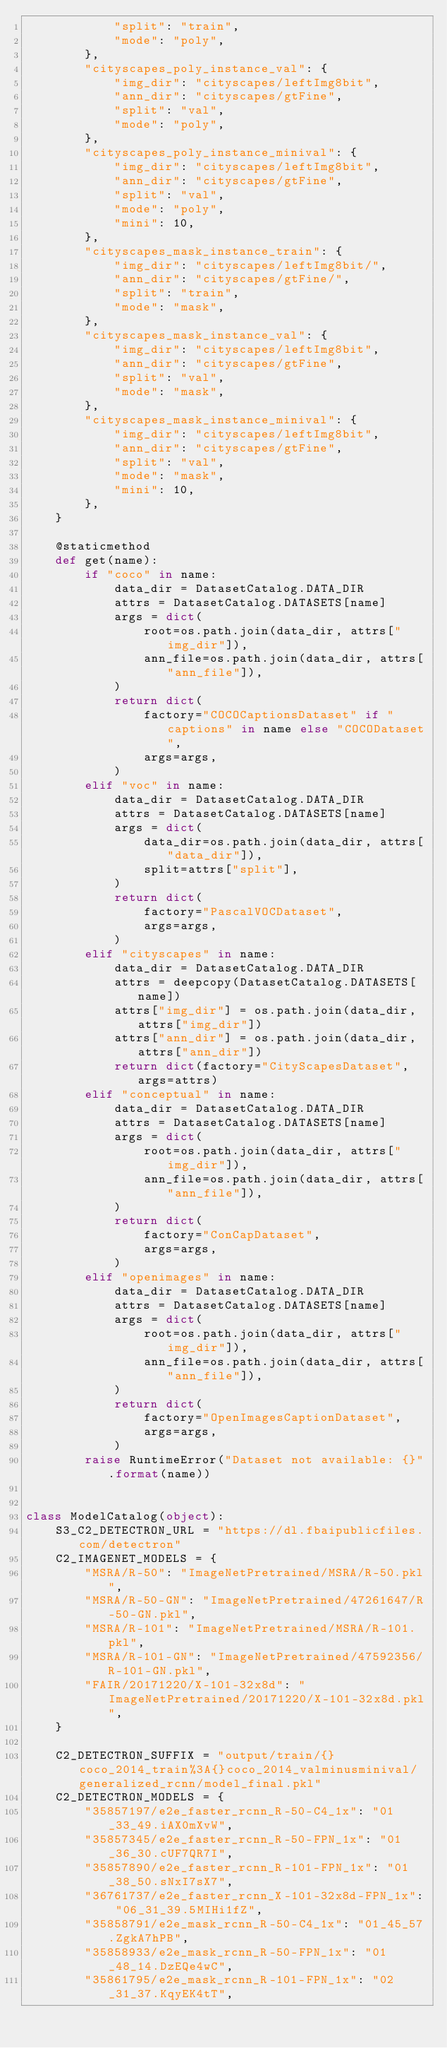<code> <loc_0><loc_0><loc_500><loc_500><_Python_>            "split": "train",
            "mode": "poly",
        },
        "cityscapes_poly_instance_val": {
            "img_dir": "cityscapes/leftImg8bit",
            "ann_dir": "cityscapes/gtFine",
            "split": "val",
            "mode": "poly",
        },
        "cityscapes_poly_instance_minival": {
            "img_dir": "cityscapes/leftImg8bit",
            "ann_dir": "cityscapes/gtFine",
            "split": "val",
            "mode": "poly",
            "mini": 10,
        },
        "cityscapes_mask_instance_train": {
            "img_dir": "cityscapes/leftImg8bit/",
            "ann_dir": "cityscapes/gtFine/",
            "split": "train",
            "mode": "mask",
        },
        "cityscapes_mask_instance_val": {
            "img_dir": "cityscapes/leftImg8bit",
            "ann_dir": "cityscapes/gtFine",
            "split": "val",
            "mode": "mask",
        },
        "cityscapes_mask_instance_minival": {
            "img_dir": "cityscapes/leftImg8bit",
            "ann_dir": "cityscapes/gtFine",
            "split": "val",
            "mode": "mask",
            "mini": 10,
        },
    }

    @staticmethod
    def get(name):
        if "coco" in name:
            data_dir = DatasetCatalog.DATA_DIR
            attrs = DatasetCatalog.DATASETS[name]
            args = dict(
                root=os.path.join(data_dir, attrs["img_dir"]),
                ann_file=os.path.join(data_dir, attrs["ann_file"]),
            )
            return dict(
                factory="COCOCaptionsDataset" if "captions" in name else "COCODataset",
                args=args,
            )
        elif "voc" in name:
            data_dir = DatasetCatalog.DATA_DIR
            attrs = DatasetCatalog.DATASETS[name]
            args = dict(
                data_dir=os.path.join(data_dir, attrs["data_dir"]),
                split=attrs["split"],
            )
            return dict(
                factory="PascalVOCDataset",
                args=args,
            )
        elif "cityscapes" in name:
            data_dir = DatasetCatalog.DATA_DIR
            attrs = deepcopy(DatasetCatalog.DATASETS[name])
            attrs["img_dir"] = os.path.join(data_dir, attrs["img_dir"])
            attrs["ann_dir"] = os.path.join(data_dir, attrs["ann_dir"])
            return dict(factory="CityScapesDataset", args=attrs)
        elif "conceptual" in name:
            data_dir = DatasetCatalog.DATA_DIR
            attrs = DatasetCatalog.DATASETS[name]
            args = dict(
                root=os.path.join(data_dir, attrs["img_dir"]),
                ann_file=os.path.join(data_dir, attrs["ann_file"]),
            )
            return dict(
                factory="ConCapDataset",
                args=args,
            )
        elif "openimages" in name:
            data_dir = DatasetCatalog.DATA_DIR
            attrs = DatasetCatalog.DATASETS[name]
            args = dict(
                root=os.path.join(data_dir, attrs["img_dir"]),
                ann_file=os.path.join(data_dir, attrs["ann_file"]),
            )
            return dict(
                factory="OpenImagesCaptionDataset",
                args=args,
            )
        raise RuntimeError("Dataset not available: {}".format(name))


class ModelCatalog(object):
    S3_C2_DETECTRON_URL = "https://dl.fbaipublicfiles.com/detectron"
    C2_IMAGENET_MODELS = {
        "MSRA/R-50": "ImageNetPretrained/MSRA/R-50.pkl",
        "MSRA/R-50-GN": "ImageNetPretrained/47261647/R-50-GN.pkl",
        "MSRA/R-101": "ImageNetPretrained/MSRA/R-101.pkl",
        "MSRA/R-101-GN": "ImageNetPretrained/47592356/R-101-GN.pkl",
        "FAIR/20171220/X-101-32x8d": "ImageNetPretrained/20171220/X-101-32x8d.pkl",
    }

    C2_DETECTRON_SUFFIX = "output/train/{}coco_2014_train%3A{}coco_2014_valminusminival/generalized_rcnn/model_final.pkl"
    C2_DETECTRON_MODELS = {
        "35857197/e2e_faster_rcnn_R-50-C4_1x": "01_33_49.iAX0mXvW",
        "35857345/e2e_faster_rcnn_R-50-FPN_1x": "01_36_30.cUF7QR7I",
        "35857890/e2e_faster_rcnn_R-101-FPN_1x": "01_38_50.sNxI7sX7",
        "36761737/e2e_faster_rcnn_X-101-32x8d-FPN_1x": "06_31_39.5MIHi1fZ",
        "35858791/e2e_mask_rcnn_R-50-C4_1x": "01_45_57.ZgkA7hPB",
        "35858933/e2e_mask_rcnn_R-50-FPN_1x": "01_48_14.DzEQe4wC",
        "35861795/e2e_mask_rcnn_R-101-FPN_1x": "02_31_37.KqyEK4tT",</code> 